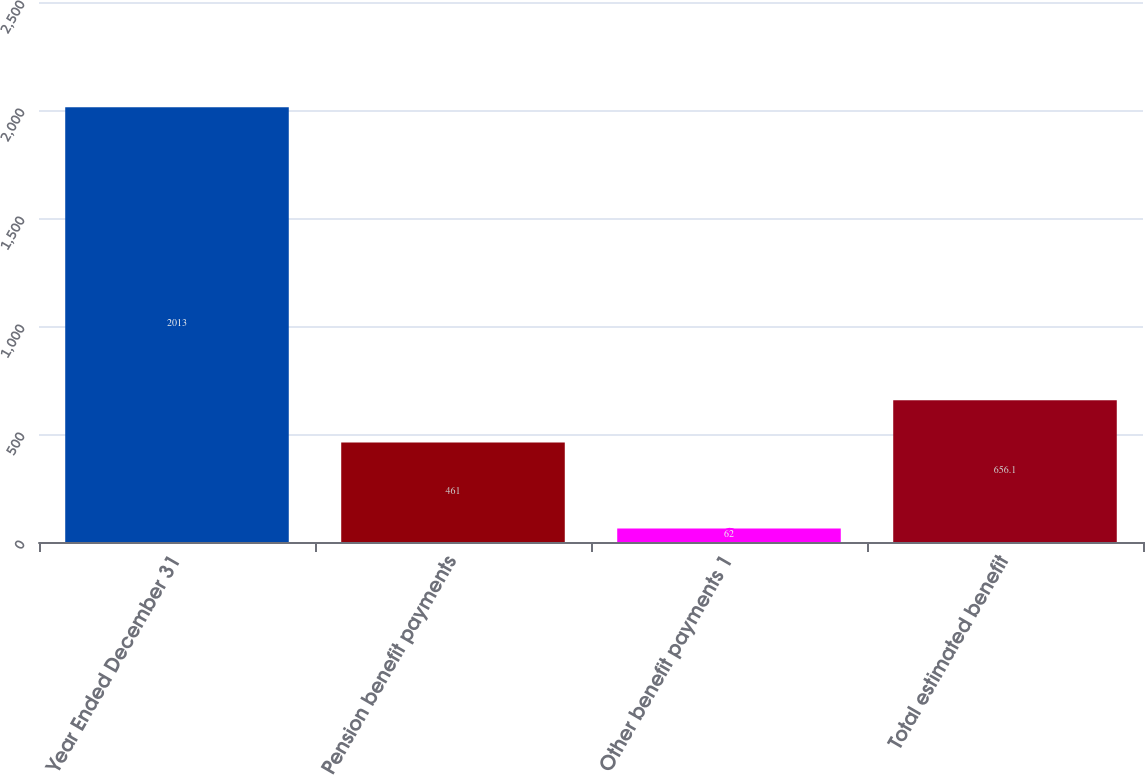Convert chart. <chart><loc_0><loc_0><loc_500><loc_500><bar_chart><fcel>Year Ended December 31<fcel>Pension benefit payments<fcel>Other benefit payments 1<fcel>Total estimated benefit<nl><fcel>2013<fcel>461<fcel>62<fcel>656.1<nl></chart> 